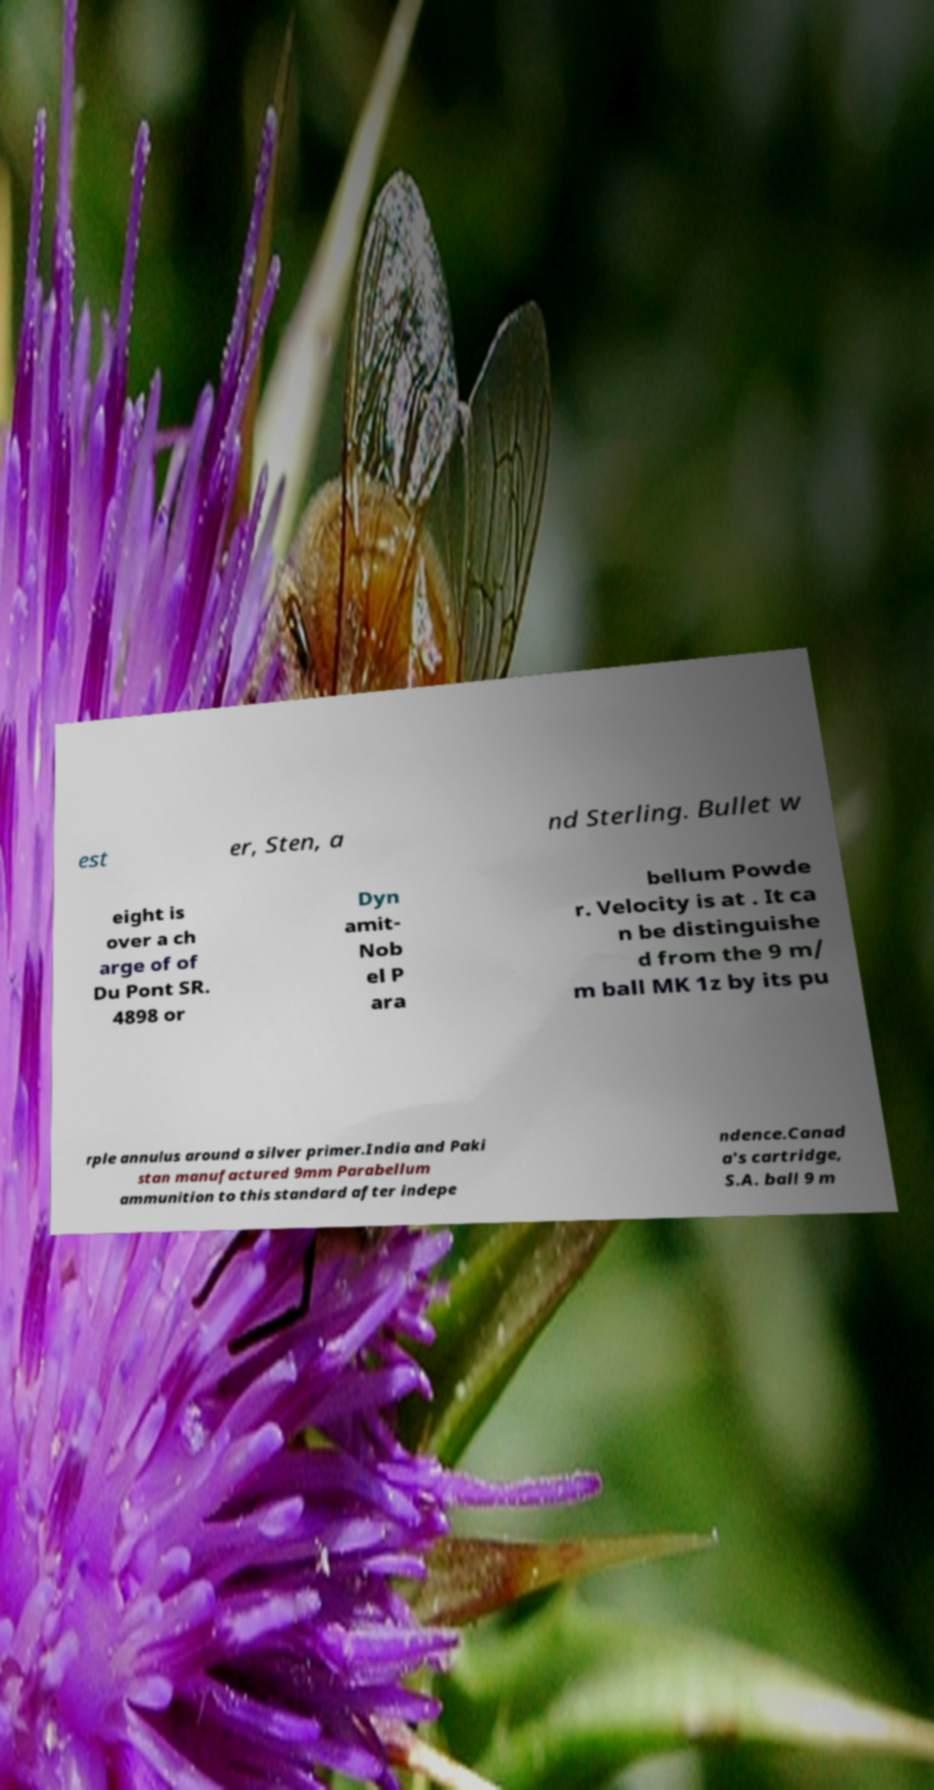Could you assist in decoding the text presented in this image and type it out clearly? est er, Sten, a nd Sterling. Bullet w eight is over a ch arge of of Du Pont SR. 4898 or Dyn amit- Nob el P ara bellum Powde r. Velocity is at . It ca n be distinguishe d from the 9 m/ m ball MK 1z by its pu rple annulus around a silver primer.India and Paki stan manufactured 9mm Parabellum ammunition to this standard after indepe ndence.Canad a's cartridge, S.A. ball 9 m 